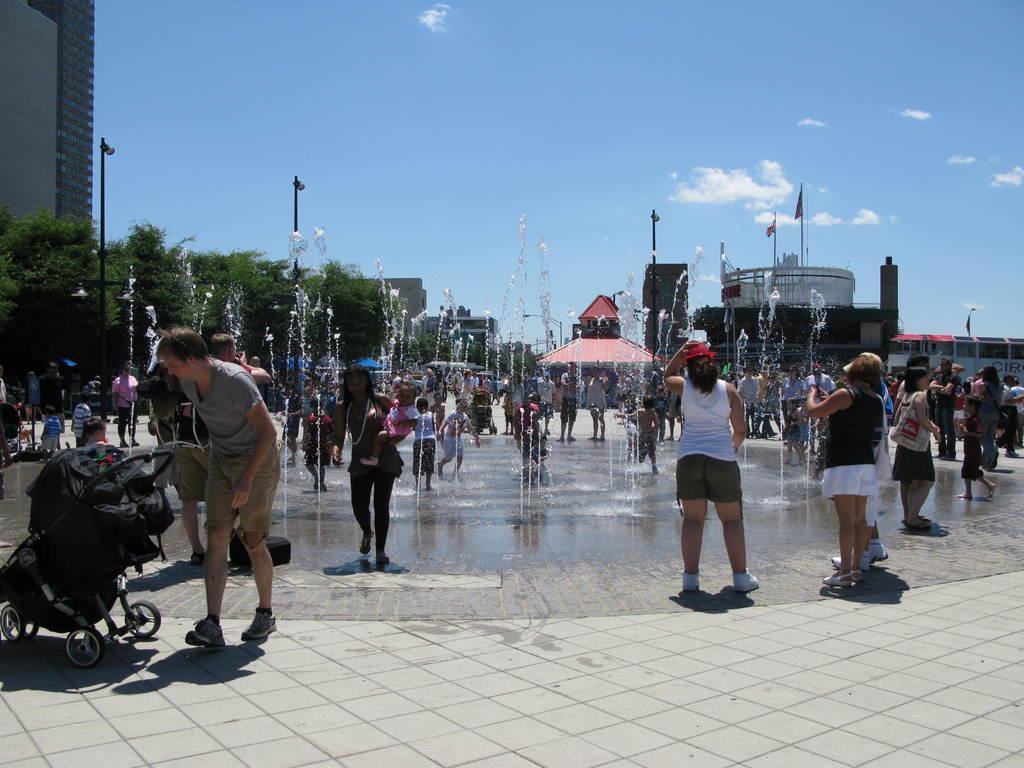Please provide a concise description of this image. In the image there are many people standing. And there are water flowing. In the background there are trees, poles and buildings. On the left side of the image there is a stroller on the ground. 